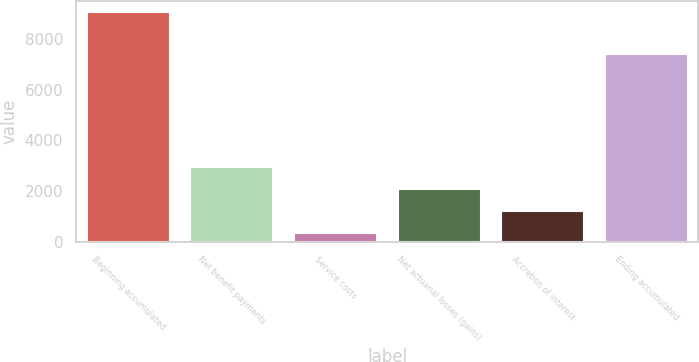<chart> <loc_0><loc_0><loc_500><loc_500><bar_chart><fcel>Beginning accumulated<fcel>Net benefit payments<fcel>Service costs<fcel>Net actuarial losses (gains)<fcel>Accretion of interest<fcel>Ending accumulated<nl><fcel>9075<fcel>2947.2<fcel>321<fcel>2071.8<fcel>1196.4<fcel>7408<nl></chart> 